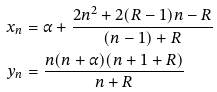Convert formula to latex. <formula><loc_0><loc_0><loc_500><loc_500>x _ { n } & = \alpha + \frac { 2 n ^ { 2 } + 2 ( R - 1 ) n - R } { ( n - 1 ) + R } \\ y _ { n } & = \frac { n ( n + \alpha ) ( n + 1 + R ) } { n + R }</formula> 